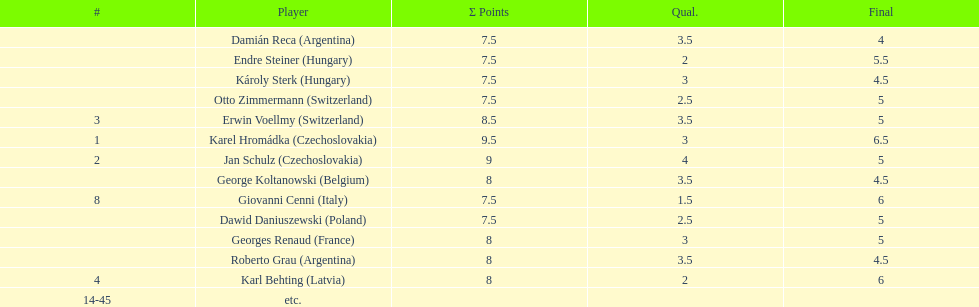Who was the top scorer from switzerland? Erwin Voellmy. Write the full table. {'header': ['#', 'Player', 'Σ Points', 'Qual.', 'Final'], 'rows': [['', 'Damián Reca\xa0(Argentina)', '7.5', '3.5', '4'], ['', 'Endre Steiner\xa0(Hungary)', '7.5', '2', '5.5'], ['', 'Károly Sterk\xa0(Hungary)', '7.5', '3', '4.5'], ['', 'Otto Zimmermann\xa0(Switzerland)', '7.5', '2.5', '5'], ['3', 'Erwin Voellmy\xa0(Switzerland)', '8.5', '3.5', '5'], ['1', 'Karel Hromádka\xa0(Czechoslovakia)', '9.5', '3', '6.5'], ['2', 'Jan Schulz\xa0(Czechoslovakia)', '9', '4', '5'], ['', 'George Koltanowski\xa0(Belgium)', '8', '3.5', '4.5'], ['8', 'Giovanni Cenni\xa0(Italy)', '7.5', '1.5', '6'], ['', 'Dawid Daniuszewski\xa0(Poland)', '7.5', '2.5', '5'], ['', 'Georges Renaud\xa0(France)', '8', '3', '5'], ['', 'Roberto Grau\xa0(Argentina)', '8', '3.5', '4.5'], ['4', 'Karl Behting\xa0(Latvia)', '8', '2', '6'], ['14-45', 'etc.', '', '', '']]} 